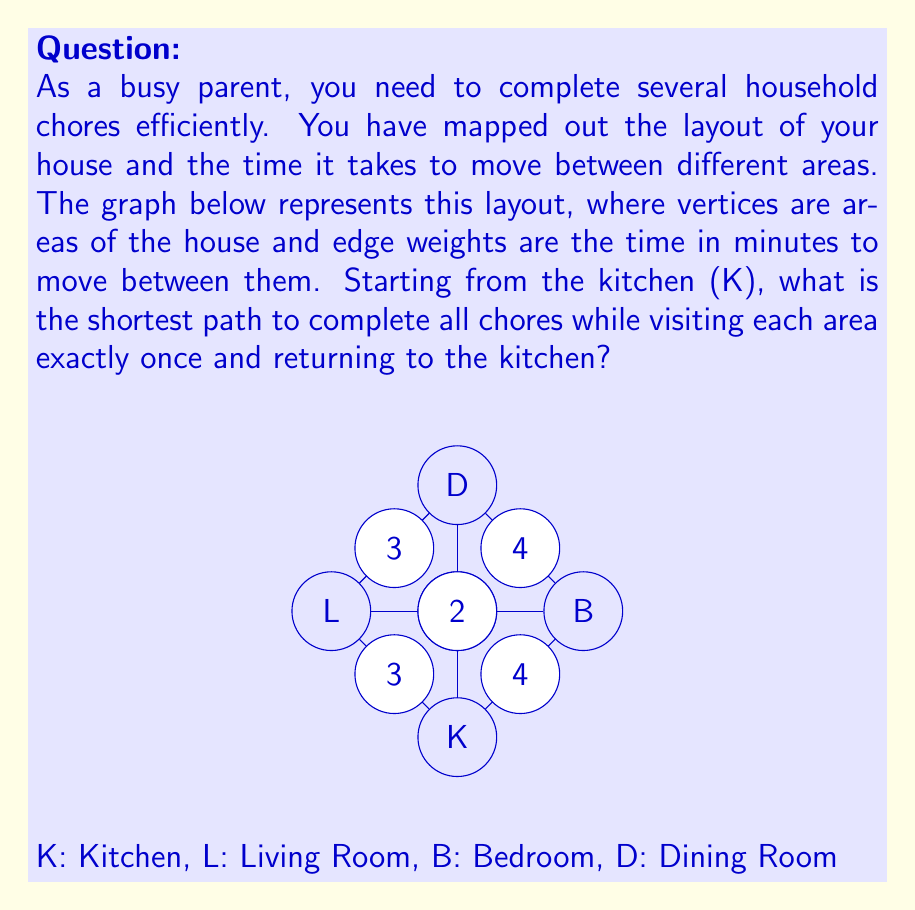Teach me how to tackle this problem. To solve this problem, we need to find the Hamiltonian cycle with the minimum total weight in the given graph. This is known as the Traveling Salesman Problem (TSP), which is NP-hard. For small graphs like this, we can solve it by enumerating all possible paths.

Possible Hamiltonian cycles starting and ending at K:
1. K → L → B → D → K
2. K → L → D → B → K
3. K → B → L → D → K
4. K → B → D → L → K
5. K → D → L → B → K
6. K → D → B → L → K

Let's calculate the total weight for each path:

1. K → L → B → D → K: 3 + 5 + 4 + 2 = 14
2. K → L → D → B → K: 3 + 3 + 4 + 4 = 14
3. K → B → L → D → K: 4 + 5 + 3 + 2 = 14
4. K → B → D → L → K: 4 + 4 + 3 + 3 = 14
5. K → D → L → B → K: 2 + 3 + 5 + 4 = 14
6. K → D → B → L → K: 2 + 4 + 5 + 3 = 14

All paths have the same total weight of 14 minutes. Therefore, any of these paths would be considered the shortest path for completing all chores efficiently.
Answer: The shortest path to complete all chores while visiting each area exactly once and returning to the kitchen takes 14 minutes. Any of the following paths achieve this:
$K \rightarrow L \rightarrow B \rightarrow D \rightarrow K$
$K \rightarrow L \rightarrow D \rightarrow B \rightarrow K$
$K \rightarrow B \rightarrow L \rightarrow D \rightarrow K$
$K \rightarrow B \rightarrow D \rightarrow L \rightarrow K$
$K \rightarrow D \rightarrow L \rightarrow B \rightarrow K$
$K \rightarrow D \rightarrow B \rightarrow L \rightarrow K$ 